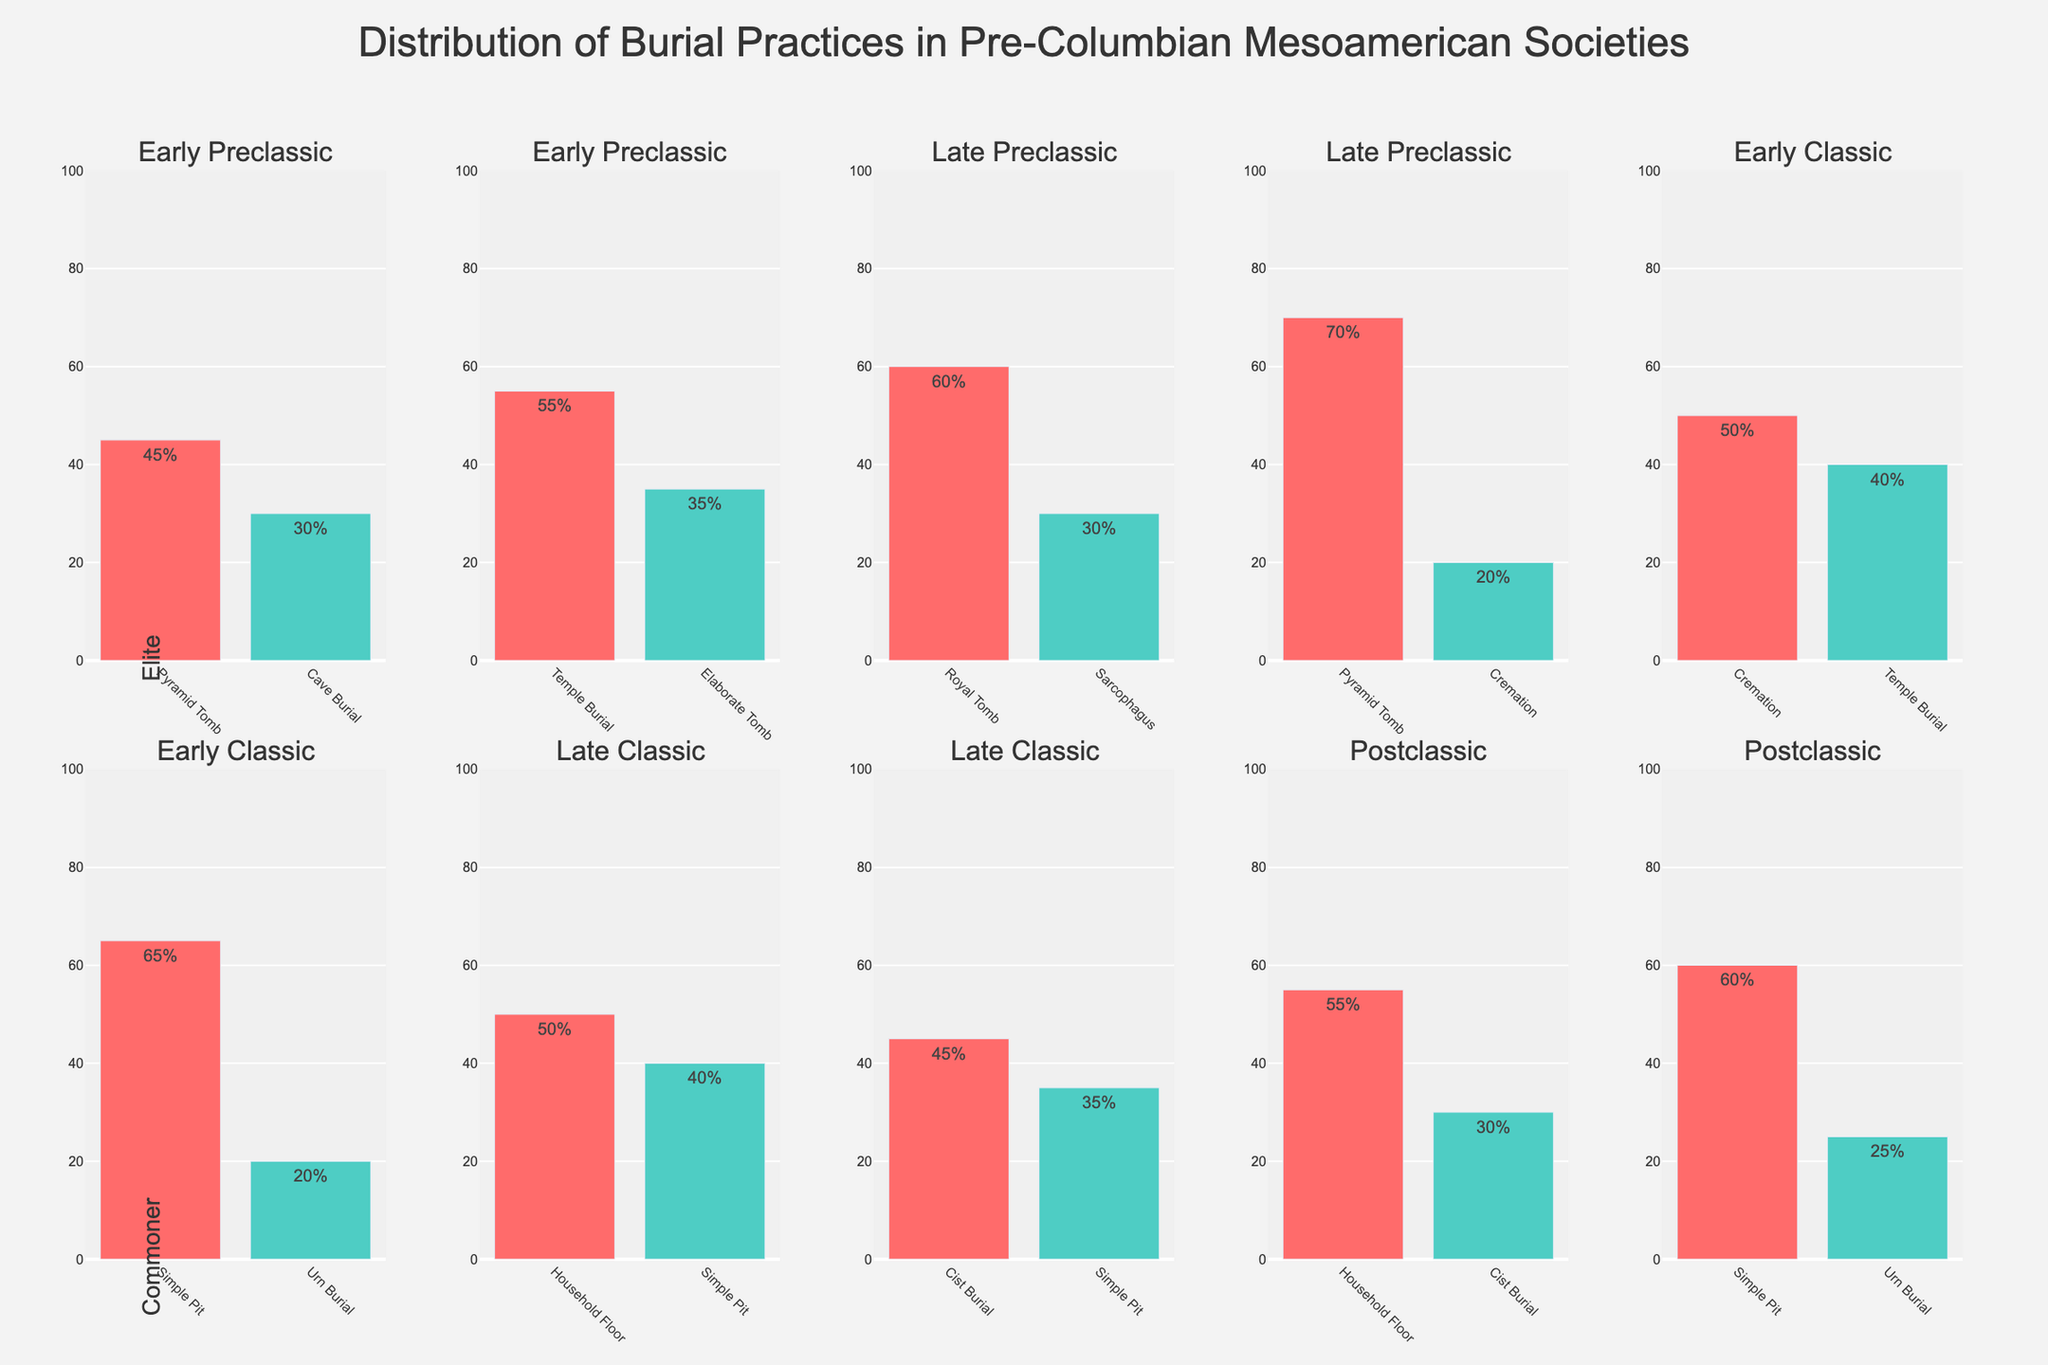What's the title of this figure? The title of a figure is typically found at the top and is intended to provide a concise description of what the figure represents. In this case, the title is "Distribution of Burial Practices in Pre-Columbian Mesoamerican Societies".
Answer: Distribution of Burial Practices in Pre-Columbian Mesoamerican Societies Which social status group uses the Pyramid Tomb practice the most in the Late Classic period? To find this, locate the subplot corresponding to the Late Classic period for the different social statuses. For the Late Classic period, look at the Elite group to see that Pyramid Tomb has the highest percentage (70%).
Answer: Elite What's the most common burial practice for commoners in the Early Preclassic period? Look at the subplot for commoners during the Early Preclassic period and identify the burial practice with the highest percentage, which is Simple Pit (65%).
Answer: Simple Pit Compare the percentage of Temple Burial for elites between the Late Preclassic and Postclassic periods. Which period has a higher percentage? Compare the subplot for elites between the Late Preclassic and Postclassic periods for Temple Burial. Late Preclassic has 55% and Postclassic has 40%; thus, Late Preclassic has the higher percentage.
Answer: Late Preclassic What percentage of Urn Burial practices are observed for commoners in the Early Preclassic and Postclassic periods combined? Add the percentages of Urn Burial for commoners in the Early Preclassic (20%) and Postclassic (25%) periods. The total is 20% + 25% = 45%.
Answer: 45% Which burial practice shows a significant increase in usage among elites from Early Classic to Late Classic periods? Look at the subplots for the Early Classic and Late Classic periods for elites and identify any practices showing a marked increase. Pyramid Tomb increases from 60% to 70%.
Answer: Pyramid Tomb Is there any burial practice exclusive to commoners in any time period? Look through each subplot across time periods for any burial practices that appear only for commoners and not for elites. Simple Pit appears exclusively among commoners across all periods.
Answer: Simple Pit What's the difference in percentage points between the most common and least common burial practice for elites in the Early Classic period? Identify the most common (Royal Tomb, 60%) and the least common (Sarcophagus, 30%) practices for elites in the Early Classic period. Calculate the difference: 60% - 30% = 30%.
Answer: 30% Which burial practice for elites in the Postclassic period is nearly as common as Simple Pit burial for commoners in the same period? For the Postclassic period, compare the Elites’ burial practices with the commoners' Simple Pit (60%). Cremation for elites is 50%, closest to 60%.
Answer: Cremation 